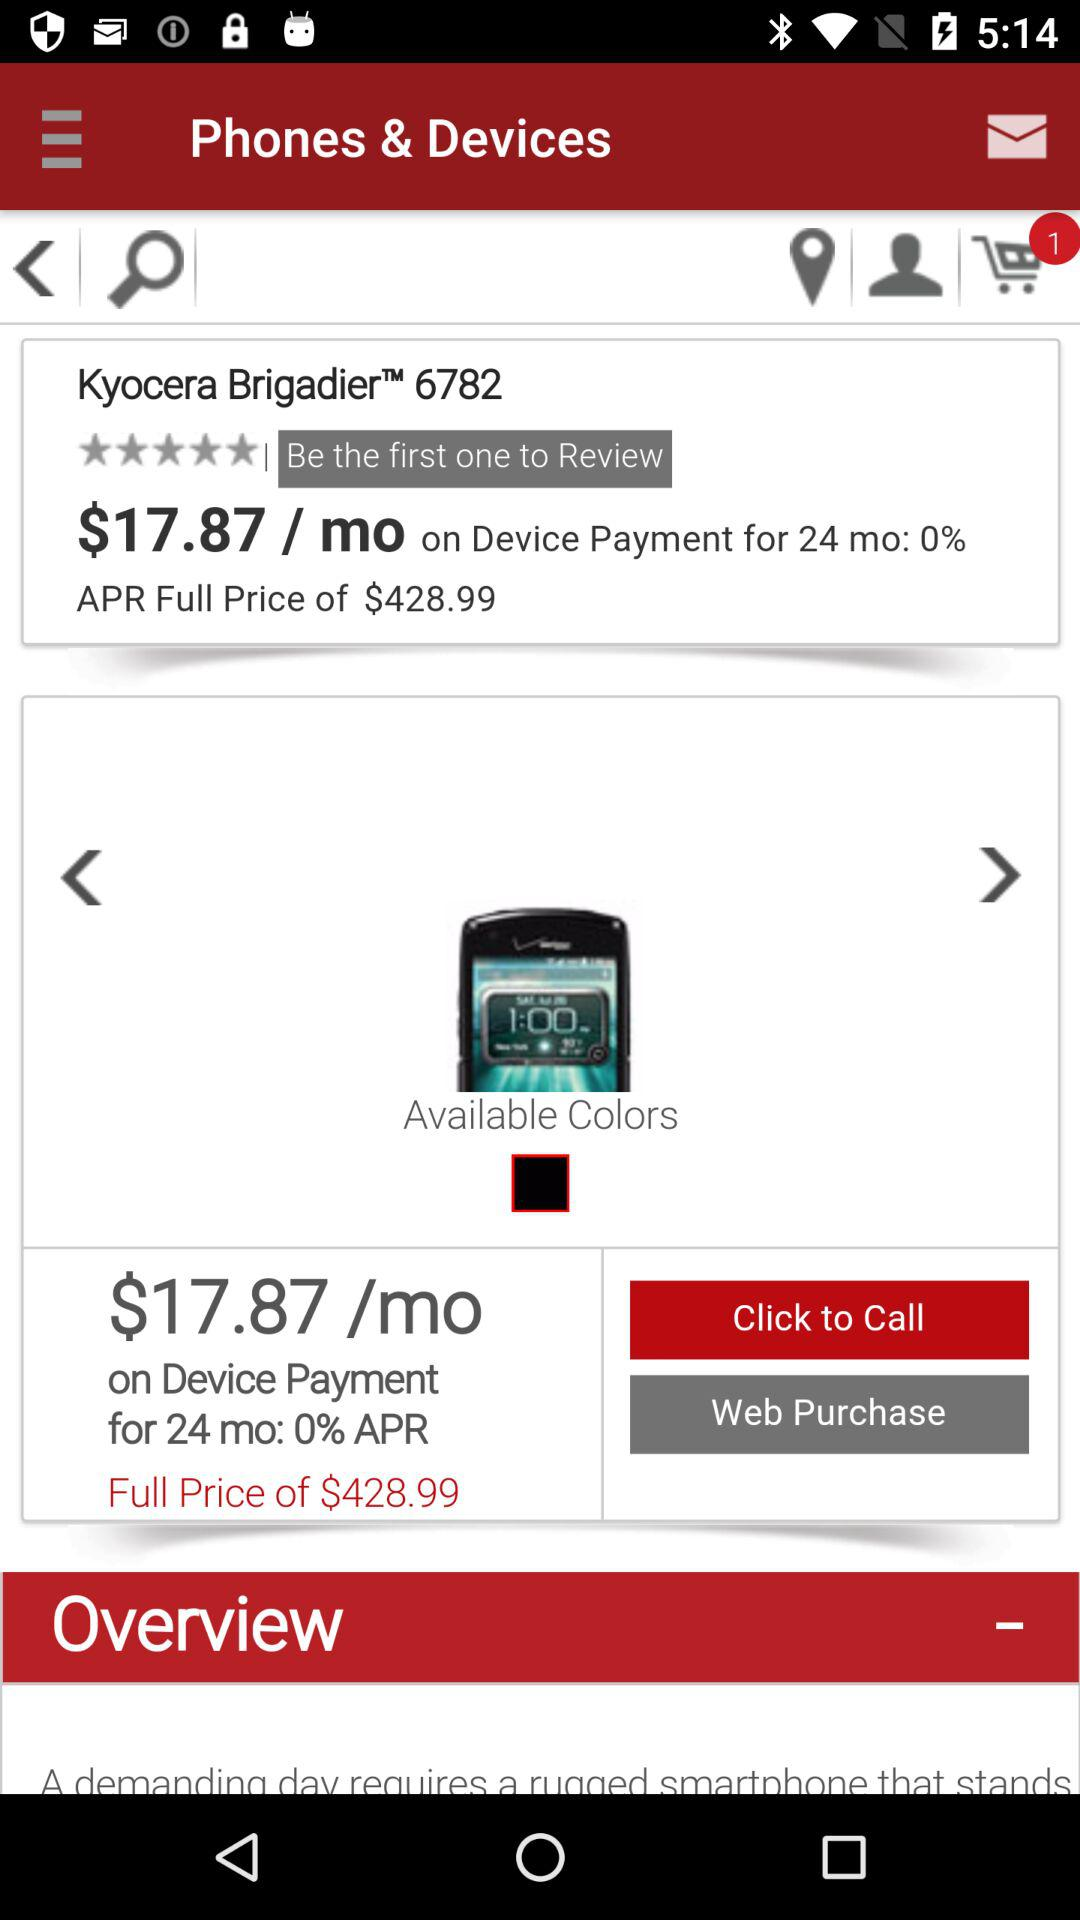How much is the monthly payment on the Kyocera BrigadierTM 6782 if paid over 24 months?
Answer the question using a single word or phrase. $17.87 